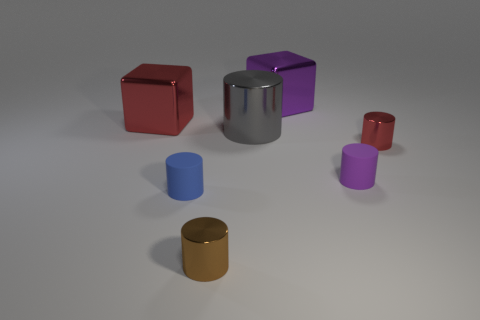What material is the red object that is the same shape as the gray thing?
Make the answer very short. Metal. What number of red shiny objects are the same shape as the purple rubber thing?
Ensure brevity in your answer.  1. What number of large purple metal blocks are there?
Give a very brief answer. 1. The big cube left of the small matte cylinder that is left of the big purple metallic thing is what color?
Provide a short and direct response. Red. What is the color of the other rubber cylinder that is the same size as the purple rubber cylinder?
Your answer should be very brief. Blue. Is there a metallic thing that has the same color as the large cylinder?
Keep it short and to the point. No. Are any large red metal things visible?
Your response must be concise. Yes. The small brown thing left of the big gray metallic cylinder has what shape?
Provide a succinct answer. Cylinder. What number of metallic things are in front of the large purple metallic block and on the left side of the tiny red metal object?
Offer a very short reply. 3. How many other objects are the same size as the blue object?
Offer a very short reply. 3. 